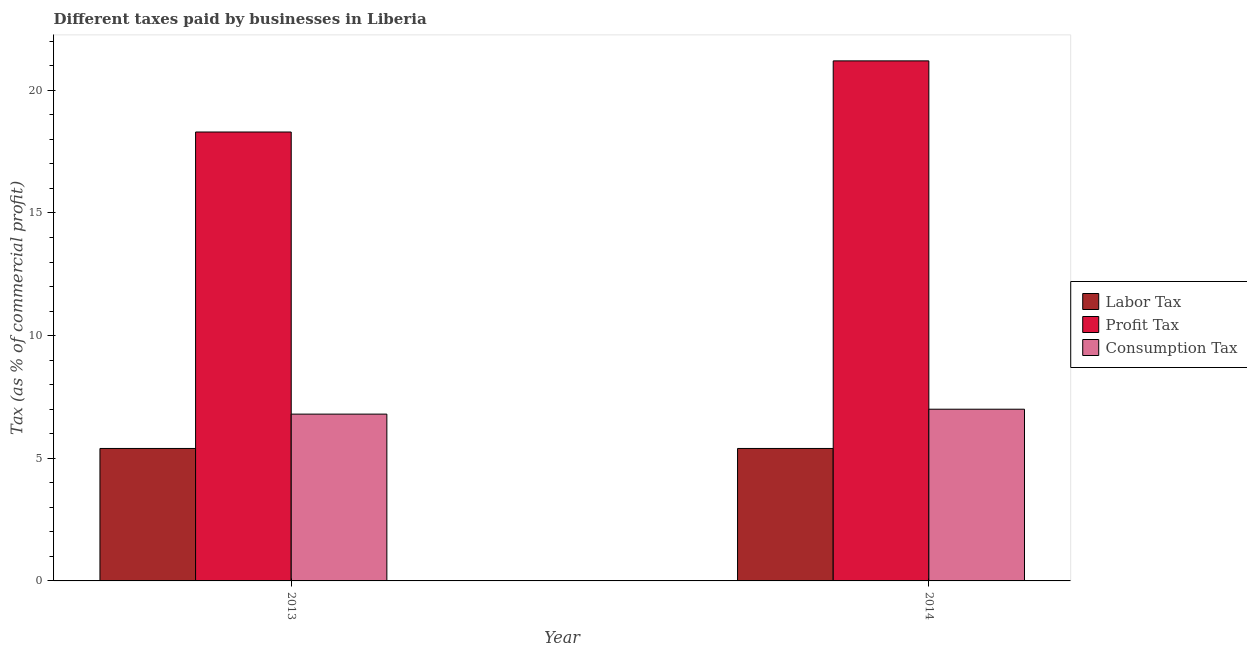How many different coloured bars are there?
Provide a short and direct response. 3. How many groups of bars are there?
Make the answer very short. 2. What is the label of the 1st group of bars from the left?
Make the answer very short. 2013. In how many cases, is the number of bars for a given year not equal to the number of legend labels?
Keep it short and to the point. 0. What is the percentage of labor tax in 2014?
Ensure brevity in your answer.  5.4. In which year was the percentage of labor tax minimum?
Your response must be concise. 2013. What is the total percentage of profit tax in the graph?
Your answer should be very brief. 39.5. What is the difference between the percentage of labor tax in 2013 and that in 2014?
Provide a short and direct response. 0. What is the difference between the percentage of consumption tax in 2013 and the percentage of profit tax in 2014?
Make the answer very short. -0.2. What is the average percentage of labor tax per year?
Your answer should be compact. 5.4. In the year 2013, what is the difference between the percentage of labor tax and percentage of profit tax?
Provide a short and direct response. 0. Is the percentage of consumption tax in 2013 less than that in 2014?
Make the answer very short. Yes. In how many years, is the percentage of profit tax greater than the average percentage of profit tax taken over all years?
Provide a short and direct response. 1. What does the 2nd bar from the left in 2013 represents?
Your answer should be compact. Profit Tax. What does the 2nd bar from the right in 2013 represents?
Make the answer very short. Profit Tax. Is it the case that in every year, the sum of the percentage of labor tax and percentage of profit tax is greater than the percentage of consumption tax?
Ensure brevity in your answer.  Yes. How many bars are there?
Make the answer very short. 6. Are all the bars in the graph horizontal?
Offer a very short reply. No. Are the values on the major ticks of Y-axis written in scientific E-notation?
Make the answer very short. No. Does the graph contain any zero values?
Offer a very short reply. No. Does the graph contain grids?
Your answer should be very brief. No. How many legend labels are there?
Offer a very short reply. 3. How are the legend labels stacked?
Offer a terse response. Vertical. What is the title of the graph?
Offer a terse response. Different taxes paid by businesses in Liberia. What is the label or title of the X-axis?
Offer a very short reply. Year. What is the label or title of the Y-axis?
Your answer should be compact. Tax (as % of commercial profit). What is the Tax (as % of commercial profit) of Labor Tax in 2013?
Keep it short and to the point. 5.4. What is the Tax (as % of commercial profit) in Profit Tax in 2014?
Offer a very short reply. 21.2. Across all years, what is the maximum Tax (as % of commercial profit) in Profit Tax?
Your answer should be very brief. 21.2. What is the total Tax (as % of commercial profit) in Profit Tax in the graph?
Offer a very short reply. 39.5. What is the total Tax (as % of commercial profit) of Consumption Tax in the graph?
Provide a succinct answer. 13.8. What is the difference between the Tax (as % of commercial profit) of Profit Tax in 2013 and that in 2014?
Offer a very short reply. -2.9. What is the difference between the Tax (as % of commercial profit) of Labor Tax in 2013 and the Tax (as % of commercial profit) of Profit Tax in 2014?
Offer a terse response. -15.8. What is the difference between the Tax (as % of commercial profit) in Profit Tax in 2013 and the Tax (as % of commercial profit) in Consumption Tax in 2014?
Provide a succinct answer. 11.3. What is the average Tax (as % of commercial profit) in Profit Tax per year?
Offer a very short reply. 19.75. In the year 2013, what is the difference between the Tax (as % of commercial profit) in Labor Tax and Tax (as % of commercial profit) in Consumption Tax?
Your answer should be very brief. -1.4. In the year 2013, what is the difference between the Tax (as % of commercial profit) of Profit Tax and Tax (as % of commercial profit) of Consumption Tax?
Your answer should be compact. 11.5. In the year 2014, what is the difference between the Tax (as % of commercial profit) in Labor Tax and Tax (as % of commercial profit) in Profit Tax?
Provide a succinct answer. -15.8. What is the ratio of the Tax (as % of commercial profit) in Labor Tax in 2013 to that in 2014?
Provide a short and direct response. 1. What is the ratio of the Tax (as % of commercial profit) in Profit Tax in 2013 to that in 2014?
Give a very brief answer. 0.86. What is the ratio of the Tax (as % of commercial profit) of Consumption Tax in 2013 to that in 2014?
Ensure brevity in your answer.  0.97. What is the difference between the highest and the second highest Tax (as % of commercial profit) of Labor Tax?
Provide a short and direct response. 0. What is the difference between the highest and the second highest Tax (as % of commercial profit) of Profit Tax?
Provide a succinct answer. 2.9. What is the difference between the highest and the second highest Tax (as % of commercial profit) in Consumption Tax?
Offer a terse response. 0.2. What is the difference between the highest and the lowest Tax (as % of commercial profit) in Labor Tax?
Your answer should be compact. 0. 